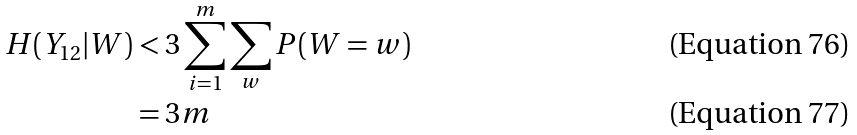Convert formula to latex. <formula><loc_0><loc_0><loc_500><loc_500>H ( { Y } _ { 1 2 } | { W } ) & < 3 \sum _ { i = 1 } ^ { m } \sum _ { w } P ( { W } = { w } ) \\ & = 3 m</formula> 